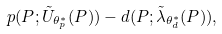Convert formula to latex. <formula><loc_0><loc_0><loc_500><loc_500>p ( P ; \tilde { U } _ { \theta _ { p } ^ { * } } ( P ) ) - d ( P ; \tilde { \lambda } _ { \theta _ { d } ^ { * } } ( P ) ) ,</formula> 